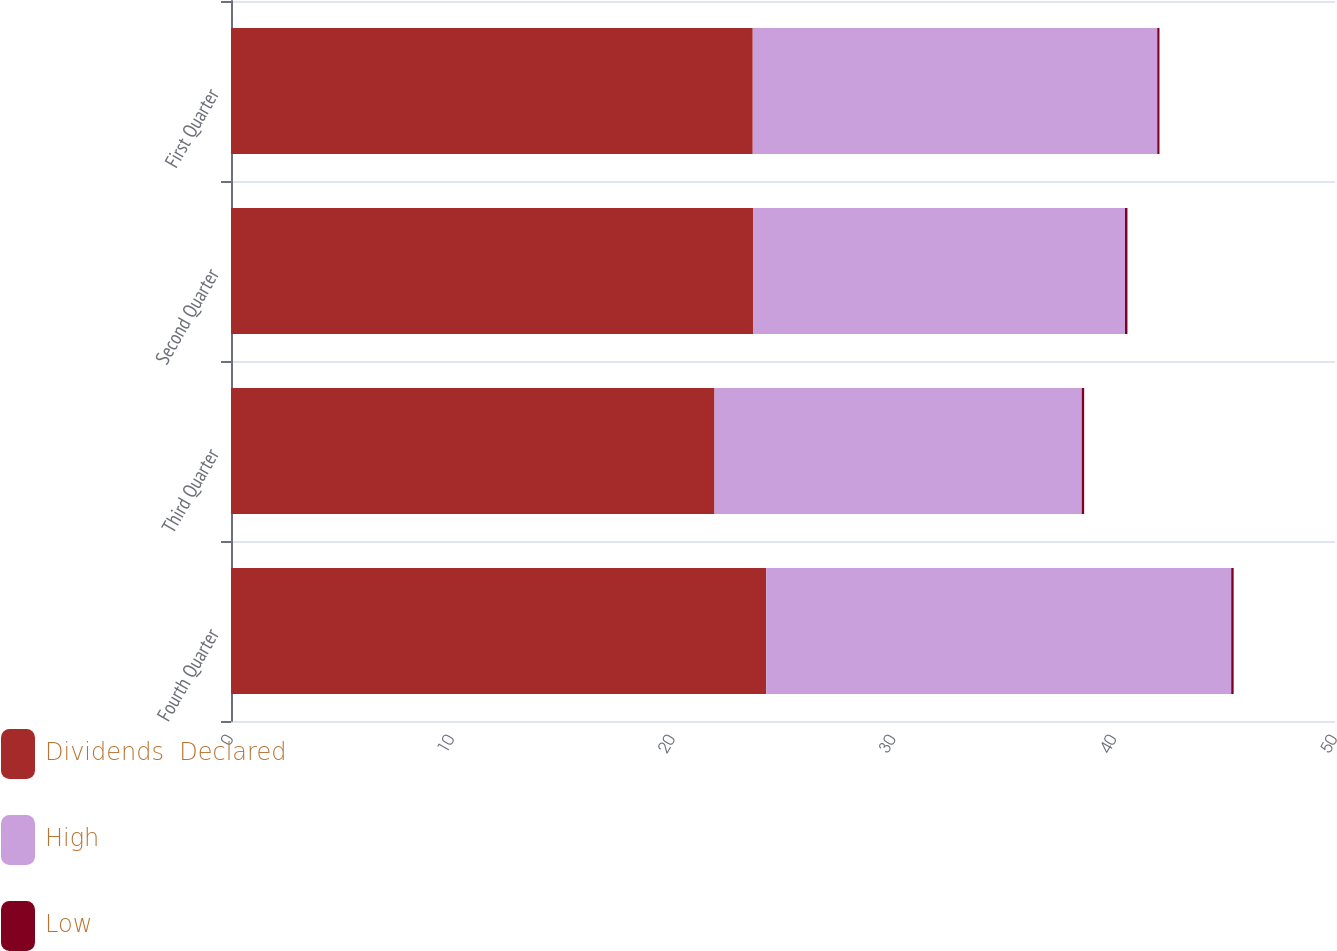Convert chart. <chart><loc_0><loc_0><loc_500><loc_500><stacked_bar_chart><ecel><fcel>Fourth Quarter<fcel>Third Quarter<fcel>Second Quarter<fcel>First Quarter<nl><fcel>Dividends  Declared<fcel>24.24<fcel>21.9<fcel>23.66<fcel>23.63<nl><fcel>High<fcel>21.06<fcel>16.63<fcel>16.83<fcel>18.32<nl><fcel>Low<fcel>0.11<fcel>0.11<fcel>0.11<fcel>0.1<nl></chart> 